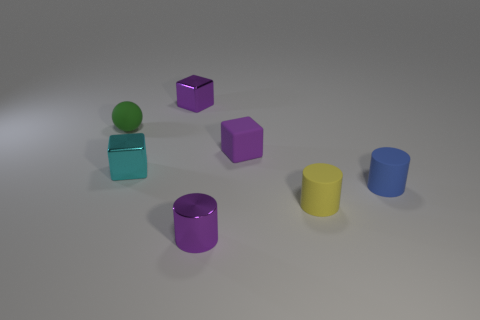There is a shiny block behind the cyan cube; is it the same color as the tiny cylinder to the left of the tiny purple rubber cube?
Keep it short and to the point. Yes. There is a object that is on the right side of the purple cylinder and on the left side of the yellow rubber cylinder; what is its color?
Keep it short and to the point. Purple. Do the purple cylinder and the tiny cyan block have the same material?
Your response must be concise. Yes. What number of large objects are either rubber blocks or purple metallic cylinders?
Provide a succinct answer. 0. Is there anything else that is the same shape as the small green thing?
Offer a terse response. No. What color is the tiny cube that is the same material as the blue cylinder?
Your answer should be compact. Purple. What is the color of the rubber thing that is behind the small rubber cube?
Offer a terse response. Green. What number of tiny matte spheres have the same color as the small metallic cylinder?
Make the answer very short. 0. Is the number of tiny cyan shiny cubes that are on the right side of the cyan shiny cube less than the number of tiny purple metallic things behind the green ball?
Give a very brief answer. Yes. What number of small cylinders are to the left of the yellow rubber object?
Provide a succinct answer. 1. 